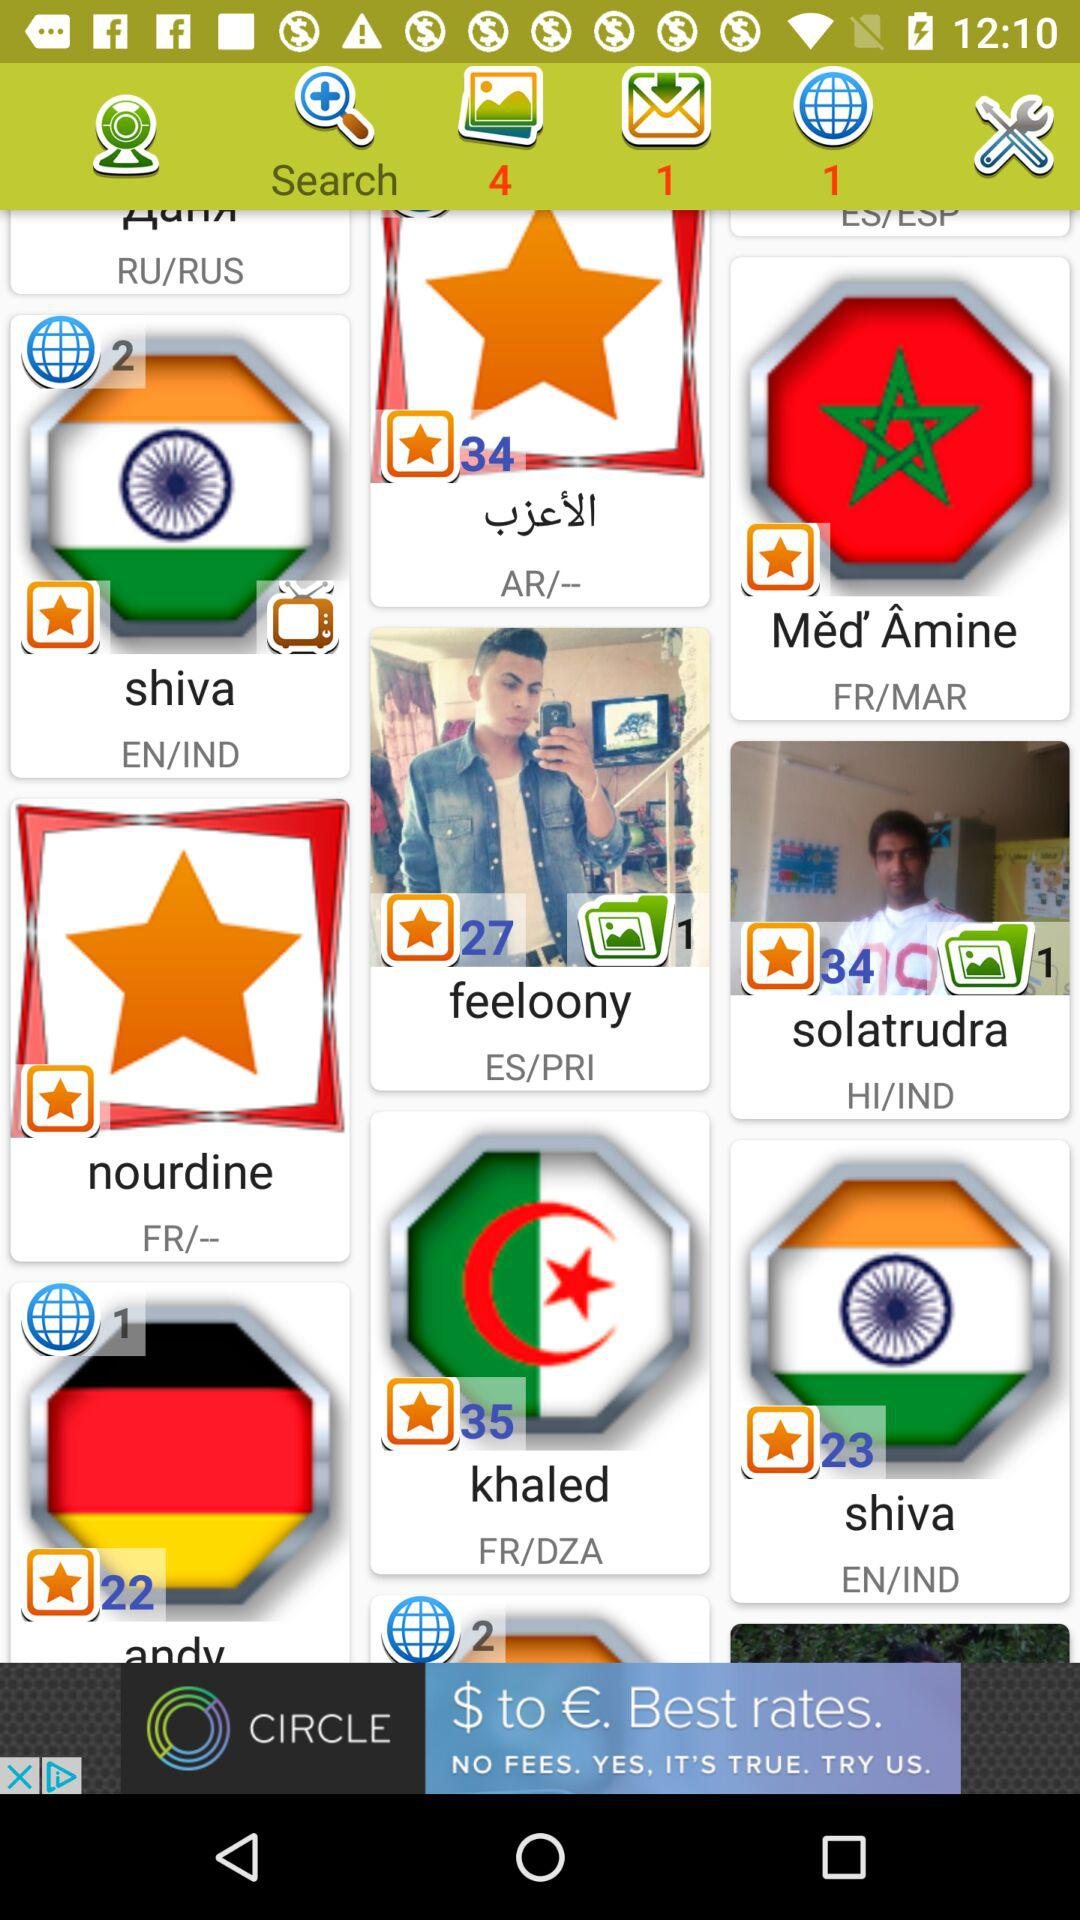Who got the 35 ratings? The 35 ratings were got by Khaled. 